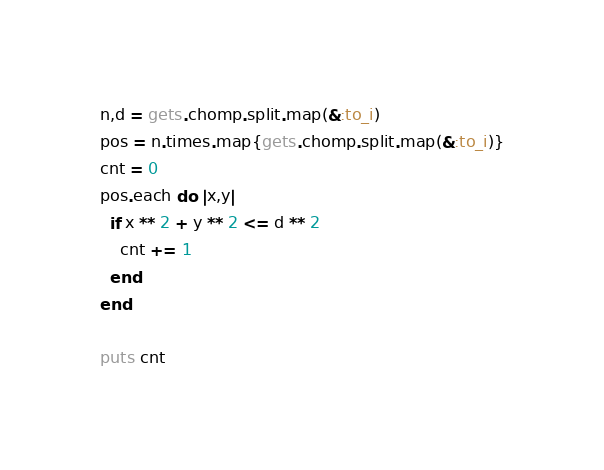<code> <loc_0><loc_0><loc_500><loc_500><_Ruby_>n,d = gets.chomp.split.map(&:to_i)
pos = n.times.map{gets.chomp.split.map(&:to_i)}
cnt = 0
pos.each do |x,y|
  if x ** 2 + y ** 2 <= d ** 2
    cnt += 1
  end
end

puts cnt
</code> 